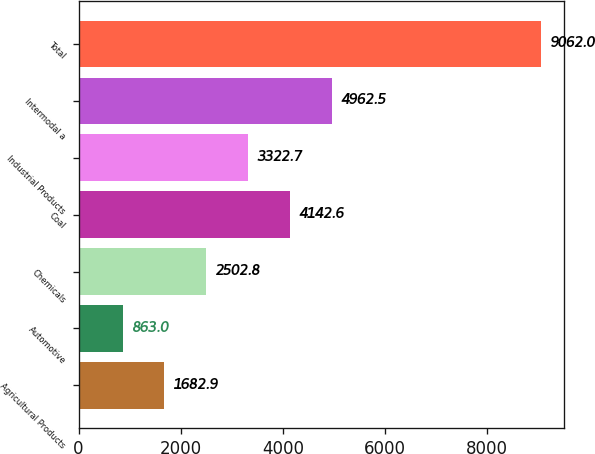Convert chart. <chart><loc_0><loc_0><loc_500><loc_500><bar_chart><fcel>Agricultural Products<fcel>Automotive<fcel>Chemicals<fcel>Coal<fcel>Industrial Products<fcel>Intermodal a<fcel>Total<nl><fcel>1682.9<fcel>863<fcel>2502.8<fcel>4142.6<fcel>3322.7<fcel>4962.5<fcel>9062<nl></chart> 